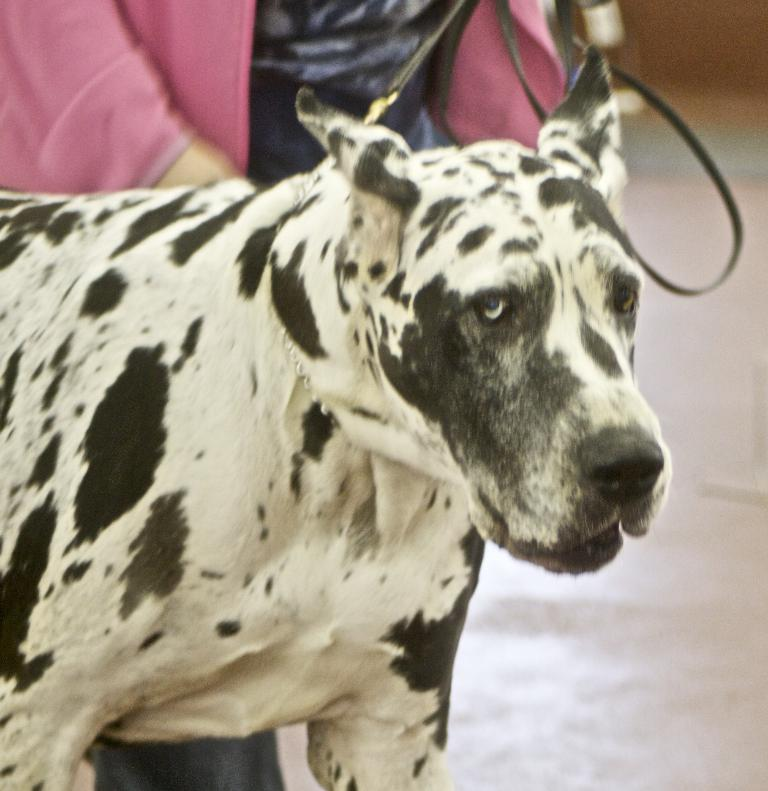Who or what is present in the image? There is a person and a dog in the image. Where are the person and the dog located? They are on a path in the image. What type of tooth is visible in the image? There is no tooth present in the image. What kind of apparel is the dog wearing in the image? The dog is not wearing any apparel in the image. 